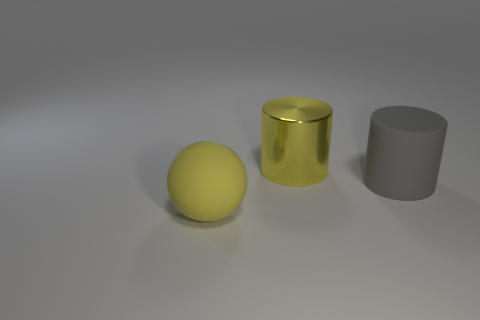Add 1 large yellow spheres. How many objects exist? 4 Subtract all cylinders. How many objects are left? 1 Add 3 big yellow matte things. How many big yellow matte things exist? 4 Subtract 0 green balls. How many objects are left? 3 Subtract all gray matte balls. Subtract all matte balls. How many objects are left? 2 Add 3 large yellow matte spheres. How many large yellow matte spheres are left? 4 